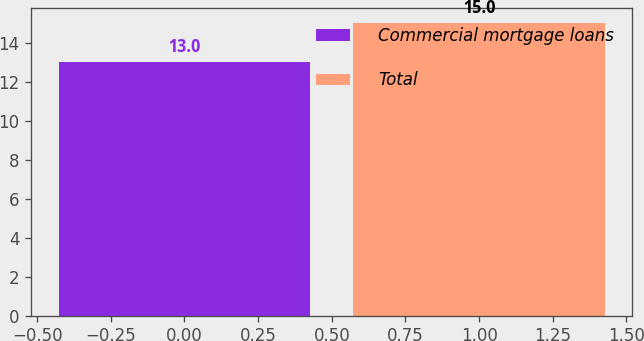<chart> <loc_0><loc_0><loc_500><loc_500><bar_chart><fcel>Commercial mortgage loans<fcel>Total<nl><fcel>13<fcel>15<nl></chart> 